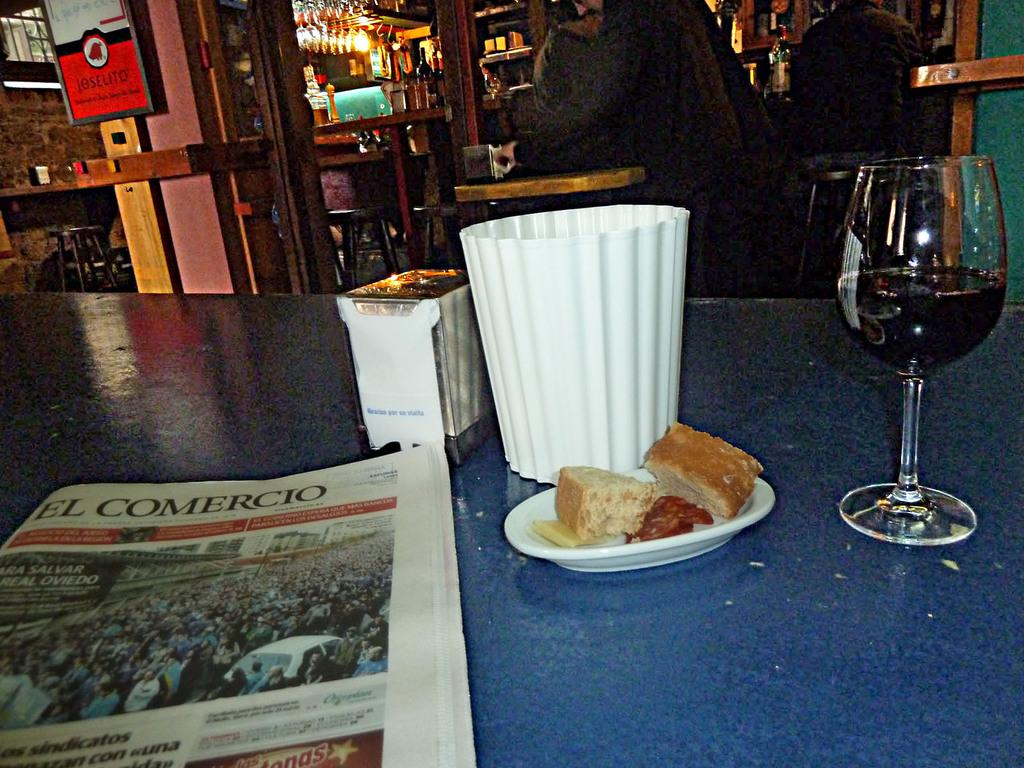<image>
Present a compact description of the photo's key features. A restaurant has a wine glass next to a paper that says El Comercio. 